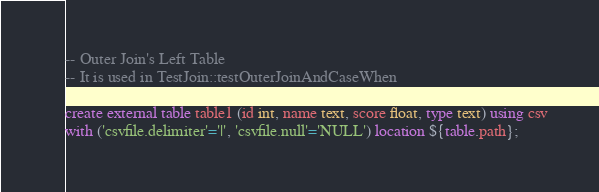Convert code to text. <code><loc_0><loc_0><loc_500><loc_500><_SQL_>-- Outer Join's Left Table
-- It is used in TestJoin::testOuterJoinAndCaseWhen

create external table table1 (id int, name text, score float, type text) using csv
with ('csvfile.delimiter'='|', 'csvfile.null'='NULL') location ${table.path};

</code> 